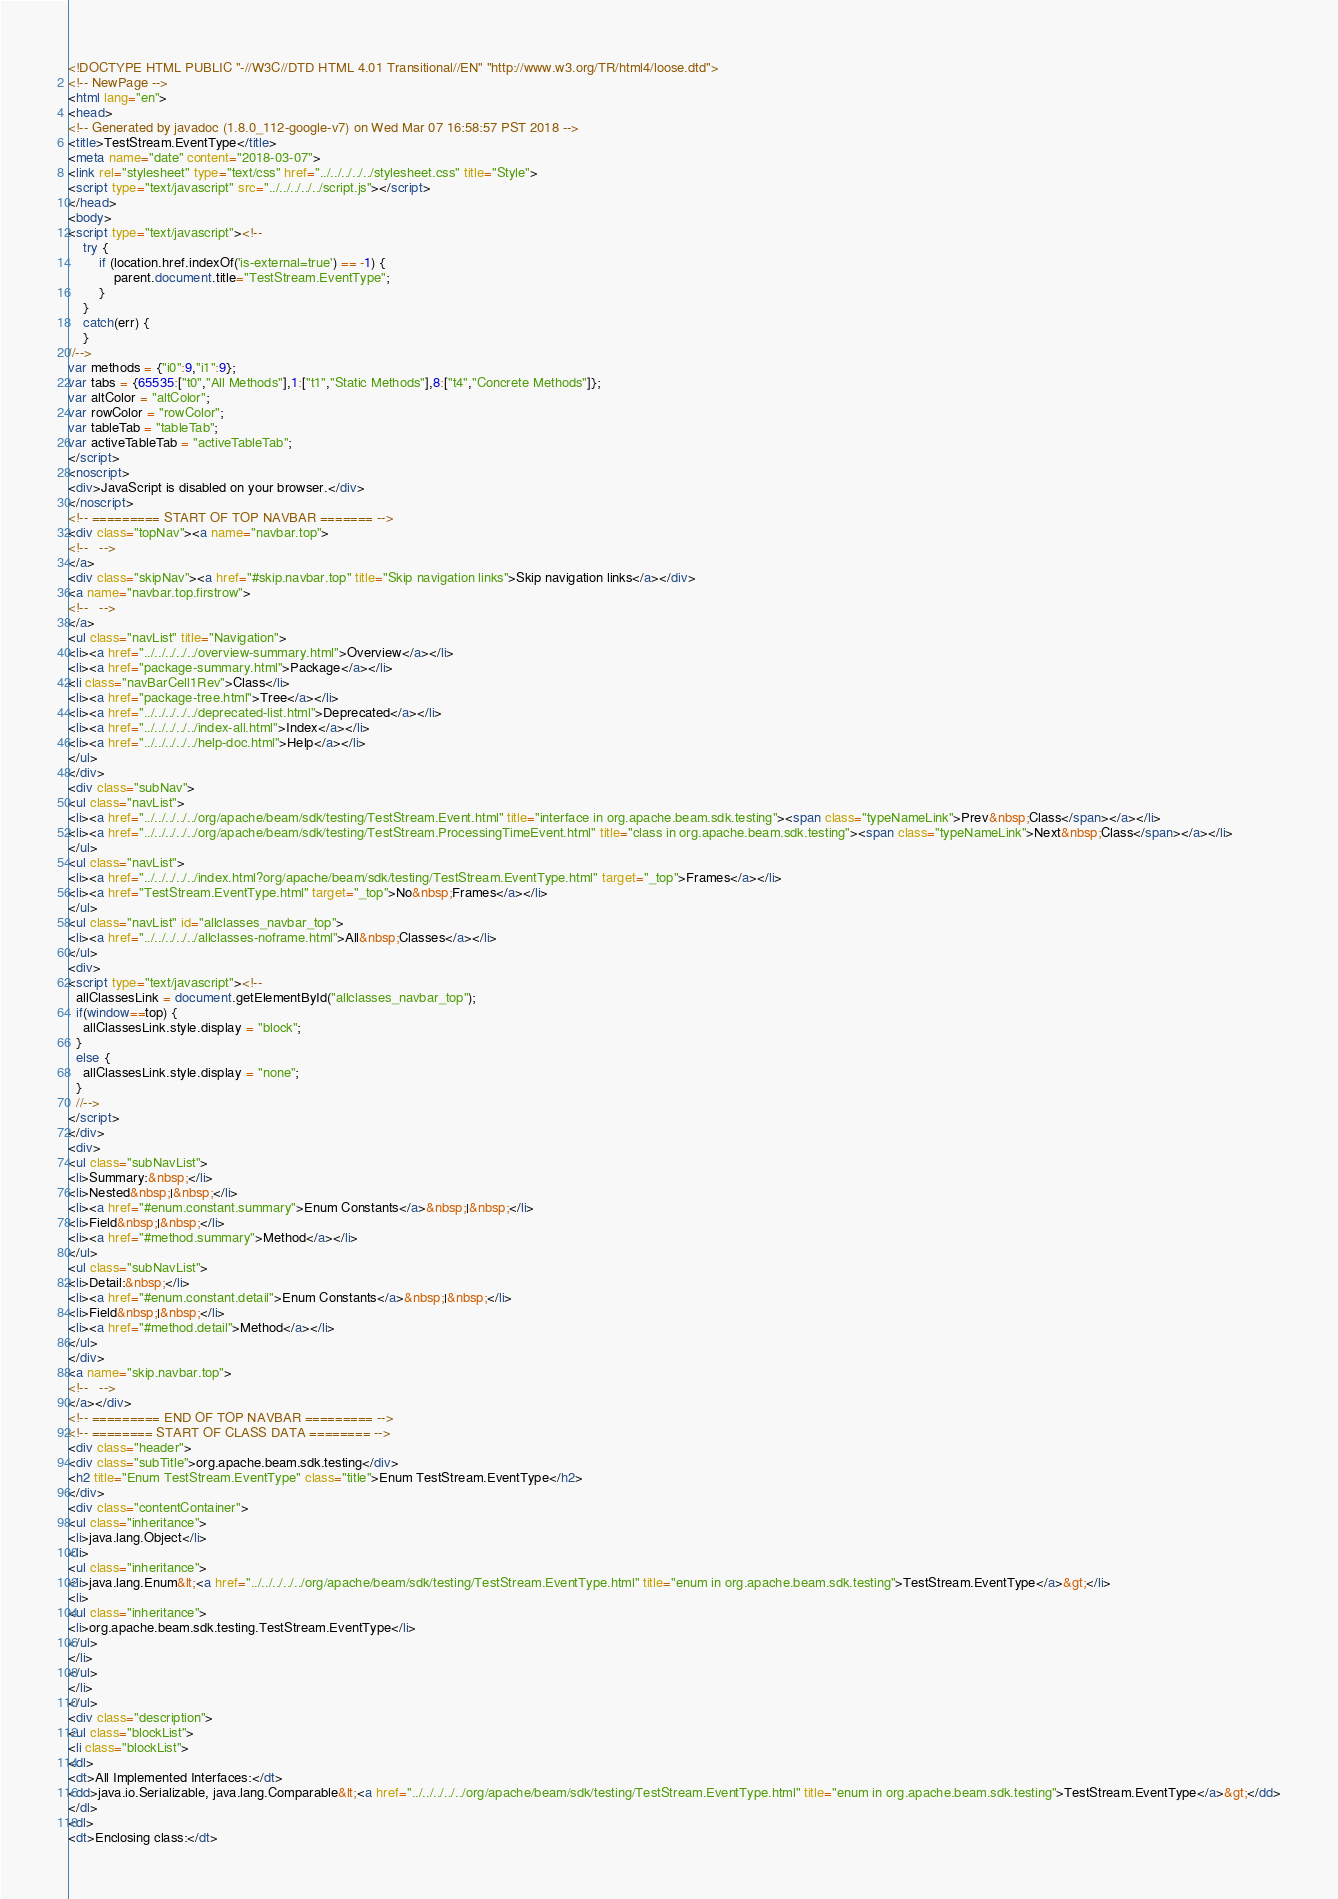Convert code to text. <code><loc_0><loc_0><loc_500><loc_500><_HTML_><!DOCTYPE HTML PUBLIC "-//W3C//DTD HTML 4.01 Transitional//EN" "http://www.w3.org/TR/html4/loose.dtd">
<!-- NewPage -->
<html lang="en">
<head>
<!-- Generated by javadoc (1.8.0_112-google-v7) on Wed Mar 07 16:58:57 PST 2018 -->
<title>TestStream.EventType</title>
<meta name="date" content="2018-03-07">
<link rel="stylesheet" type="text/css" href="../../../../../stylesheet.css" title="Style">
<script type="text/javascript" src="../../../../../script.js"></script>
</head>
<body>
<script type="text/javascript"><!--
    try {
        if (location.href.indexOf('is-external=true') == -1) {
            parent.document.title="TestStream.EventType";
        }
    }
    catch(err) {
    }
//-->
var methods = {"i0":9,"i1":9};
var tabs = {65535:["t0","All Methods"],1:["t1","Static Methods"],8:["t4","Concrete Methods"]};
var altColor = "altColor";
var rowColor = "rowColor";
var tableTab = "tableTab";
var activeTableTab = "activeTableTab";
</script>
<noscript>
<div>JavaScript is disabled on your browser.</div>
</noscript>
<!-- ========= START OF TOP NAVBAR ======= -->
<div class="topNav"><a name="navbar.top">
<!--   -->
</a>
<div class="skipNav"><a href="#skip.navbar.top" title="Skip navigation links">Skip navigation links</a></div>
<a name="navbar.top.firstrow">
<!--   -->
</a>
<ul class="navList" title="Navigation">
<li><a href="../../../../../overview-summary.html">Overview</a></li>
<li><a href="package-summary.html">Package</a></li>
<li class="navBarCell1Rev">Class</li>
<li><a href="package-tree.html">Tree</a></li>
<li><a href="../../../../../deprecated-list.html">Deprecated</a></li>
<li><a href="../../../../../index-all.html">Index</a></li>
<li><a href="../../../../../help-doc.html">Help</a></li>
</ul>
</div>
<div class="subNav">
<ul class="navList">
<li><a href="../../../../../org/apache/beam/sdk/testing/TestStream.Event.html" title="interface in org.apache.beam.sdk.testing"><span class="typeNameLink">Prev&nbsp;Class</span></a></li>
<li><a href="../../../../../org/apache/beam/sdk/testing/TestStream.ProcessingTimeEvent.html" title="class in org.apache.beam.sdk.testing"><span class="typeNameLink">Next&nbsp;Class</span></a></li>
</ul>
<ul class="navList">
<li><a href="../../../../../index.html?org/apache/beam/sdk/testing/TestStream.EventType.html" target="_top">Frames</a></li>
<li><a href="TestStream.EventType.html" target="_top">No&nbsp;Frames</a></li>
</ul>
<ul class="navList" id="allclasses_navbar_top">
<li><a href="../../../../../allclasses-noframe.html">All&nbsp;Classes</a></li>
</ul>
<div>
<script type="text/javascript"><!--
  allClassesLink = document.getElementById("allclasses_navbar_top");
  if(window==top) {
    allClassesLink.style.display = "block";
  }
  else {
    allClassesLink.style.display = "none";
  }
  //-->
</script>
</div>
<div>
<ul class="subNavList">
<li>Summary:&nbsp;</li>
<li>Nested&nbsp;|&nbsp;</li>
<li><a href="#enum.constant.summary">Enum Constants</a>&nbsp;|&nbsp;</li>
<li>Field&nbsp;|&nbsp;</li>
<li><a href="#method.summary">Method</a></li>
</ul>
<ul class="subNavList">
<li>Detail:&nbsp;</li>
<li><a href="#enum.constant.detail">Enum Constants</a>&nbsp;|&nbsp;</li>
<li>Field&nbsp;|&nbsp;</li>
<li><a href="#method.detail">Method</a></li>
</ul>
</div>
<a name="skip.navbar.top">
<!--   -->
</a></div>
<!-- ========= END OF TOP NAVBAR ========= -->
<!-- ======== START OF CLASS DATA ======== -->
<div class="header">
<div class="subTitle">org.apache.beam.sdk.testing</div>
<h2 title="Enum TestStream.EventType" class="title">Enum TestStream.EventType</h2>
</div>
<div class="contentContainer">
<ul class="inheritance">
<li>java.lang.Object</li>
<li>
<ul class="inheritance">
<li>java.lang.Enum&lt;<a href="../../../../../org/apache/beam/sdk/testing/TestStream.EventType.html" title="enum in org.apache.beam.sdk.testing">TestStream.EventType</a>&gt;</li>
<li>
<ul class="inheritance">
<li>org.apache.beam.sdk.testing.TestStream.EventType</li>
</ul>
</li>
</ul>
</li>
</ul>
<div class="description">
<ul class="blockList">
<li class="blockList">
<dl>
<dt>All Implemented Interfaces:</dt>
<dd>java.io.Serializable, java.lang.Comparable&lt;<a href="../../../../../org/apache/beam/sdk/testing/TestStream.EventType.html" title="enum in org.apache.beam.sdk.testing">TestStream.EventType</a>&gt;</dd>
</dl>
<dl>
<dt>Enclosing class:</dt></code> 